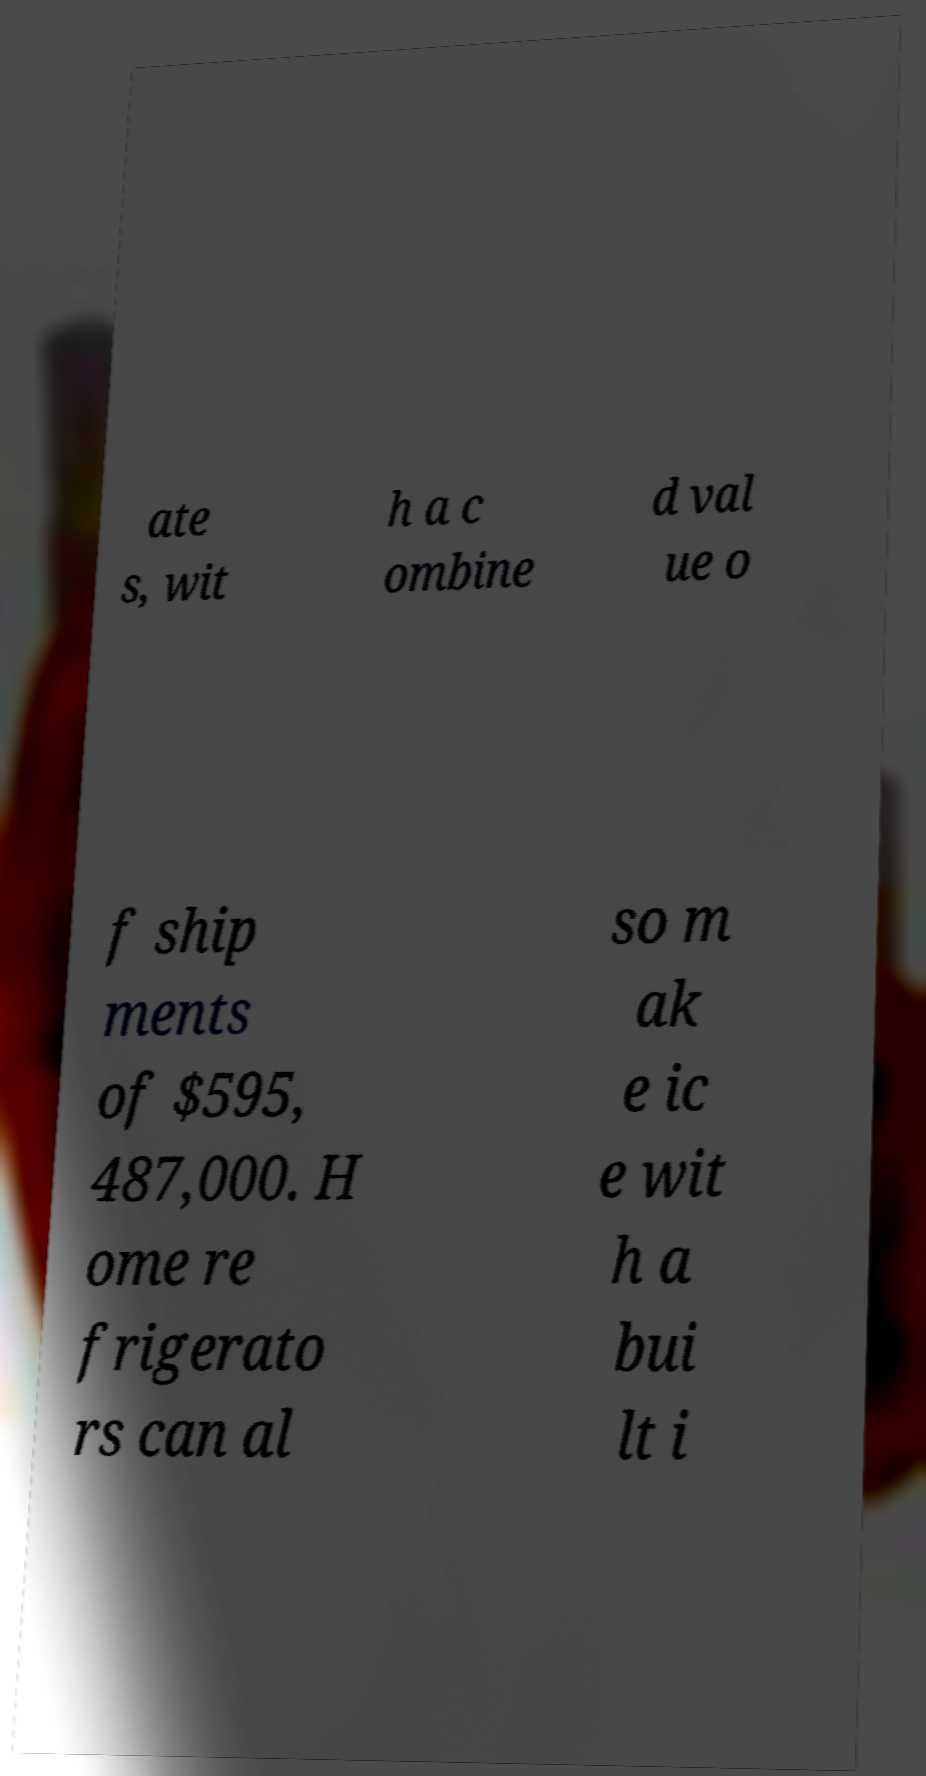I need the written content from this picture converted into text. Can you do that? ate s, wit h a c ombine d val ue o f ship ments of $595, 487,000. H ome re frigerato rs can al so m ak e ic e wit h a bui lt i 